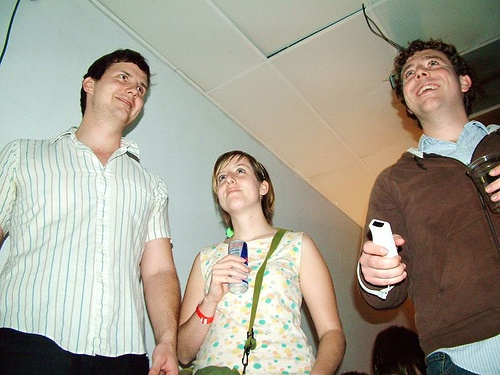Describe the objects in this image and their specific colors. I can see people in darkgray, ivory, black, and tan tones, people in darkgray, maroon, black, and tan tones, people in darkgray, beige, and tan tones, people in darkgray, black, maroon, and brown tones, and handbag in darkgray, olive, and beige tones in this image. 